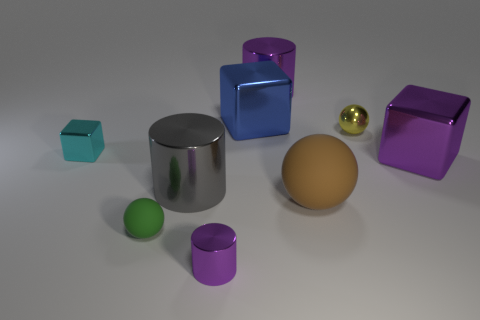Can you describe the textures and appearance of the objects in the image? The objects in the image display a variety of textures, ranging from smooth and reflective to matte. Their appearances suggest that they're likely made from materials such as polished metal or plastic, demonstrating properties like specularity and glossiness. 